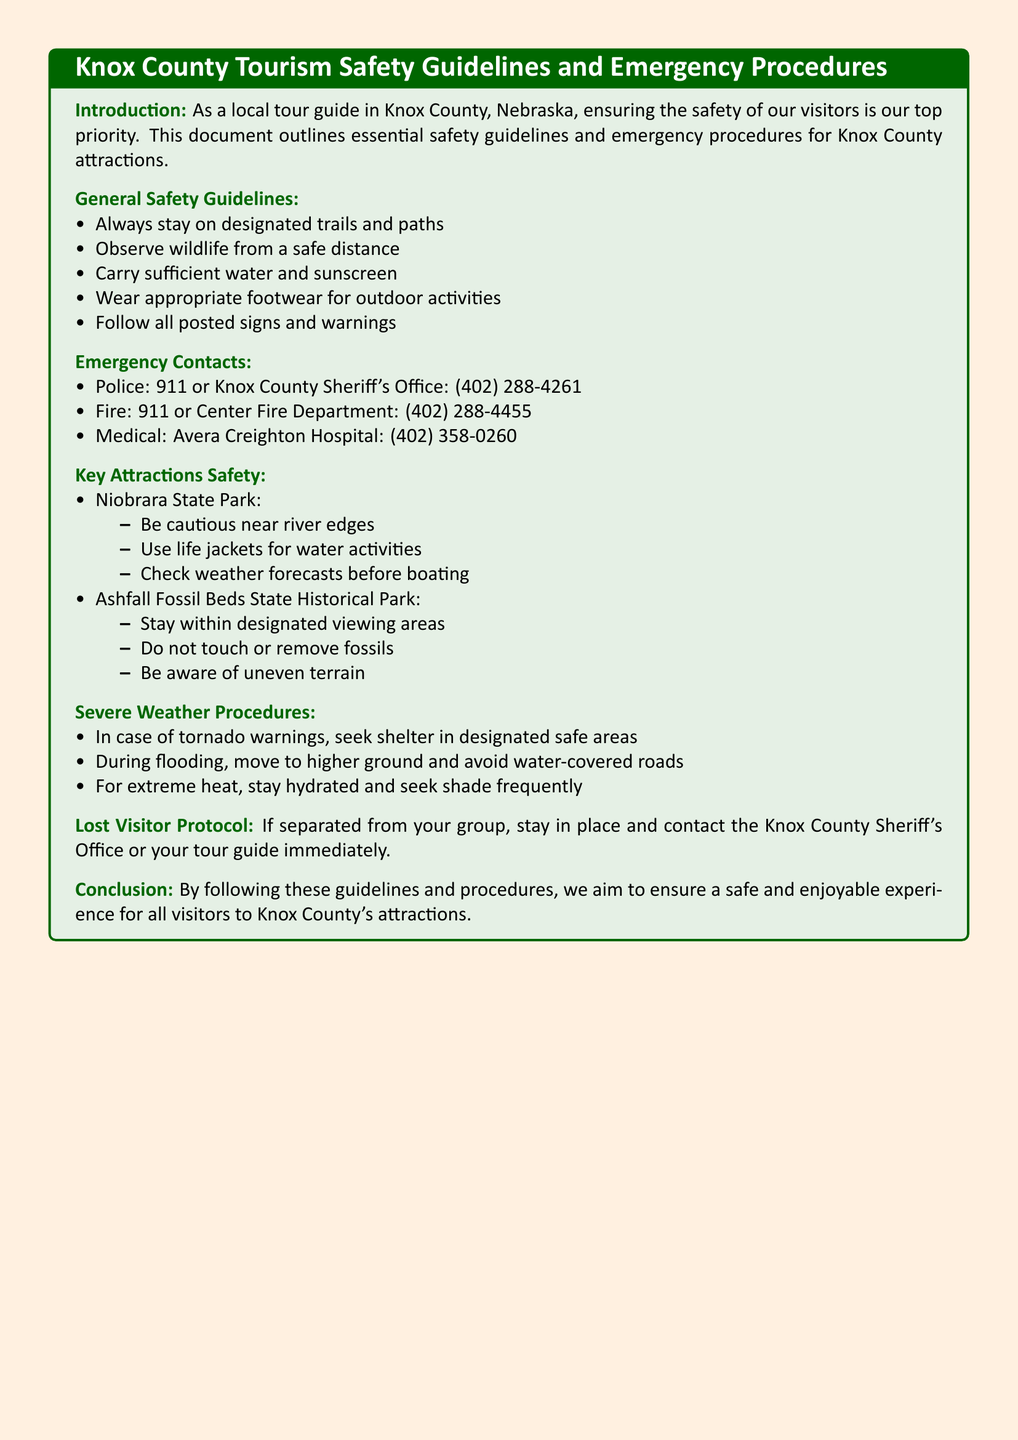What is the main priority for local tour guides? The document states that ensuring the safety of visitors is the top priority for local tour guides in Knox County.
Answer: safety of visitors What number should be dialed for the police? The document provides emergency contact information, stating the police can be reached at 911 or Knox County Sheriff's Office: (402) 288-4261.
Answer: 911 What should visitors do in case of severe weather? The document lists specific procedures during severe weather, such as seeking shelter in designated safe areas for tornado warnings.
Answer: seek shelter What is a safety guideline regarding wildlife? The document specifies that visitors should observe wildlife from a safe distance as part of the general safety guidelines.
Answer: observe from a safe distance What action should visitors take if they are lost? According to the document, if separated from the group, visitors should stay in place and contact the Knox County Sheriff's Office or their tour guide.
Answer: stay in place What specific precaution should be taken near the river at Niobrara State Park? The document advises being cautious near river edges at Niobrara State Park.
Answer: be cautious near river edges How should visitors prepare for extreme heat? The document indicates that visitors should stay hydrated and seek shade frequently during extreme heat.
Answer: stay hydrated What medical facility is mentioned in the emergency contacts? The document mentions Avera Creighton Hospital as a medical contact for emergencies.
Answer: Avera Creighton Hospital 